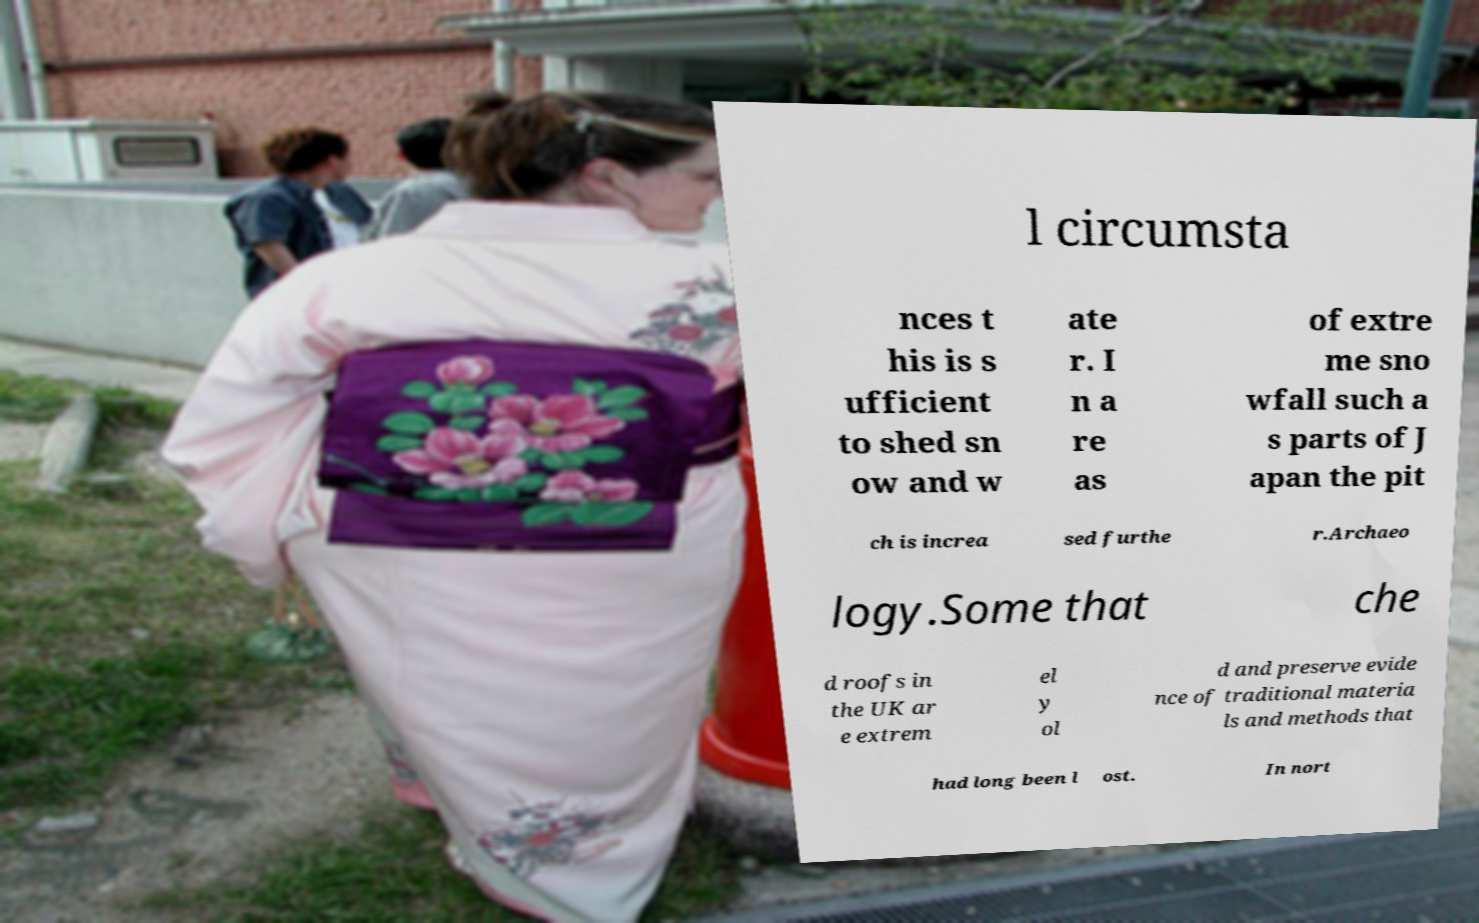For documentation purposes, I need the text within this image transcribed. Could you provide that? l circumsta nces t his is s ufficient to shed sn ow and w ate r. I n a re as of extre me sno wfall such a s parts of J apan the pit ch is increa sed furthe r.Archaeo logy.Some that che d roofs in the UK ar e extrem el y ol d and preserve evide nce of traditional materia ls and methods that had long been l ost. In nort 